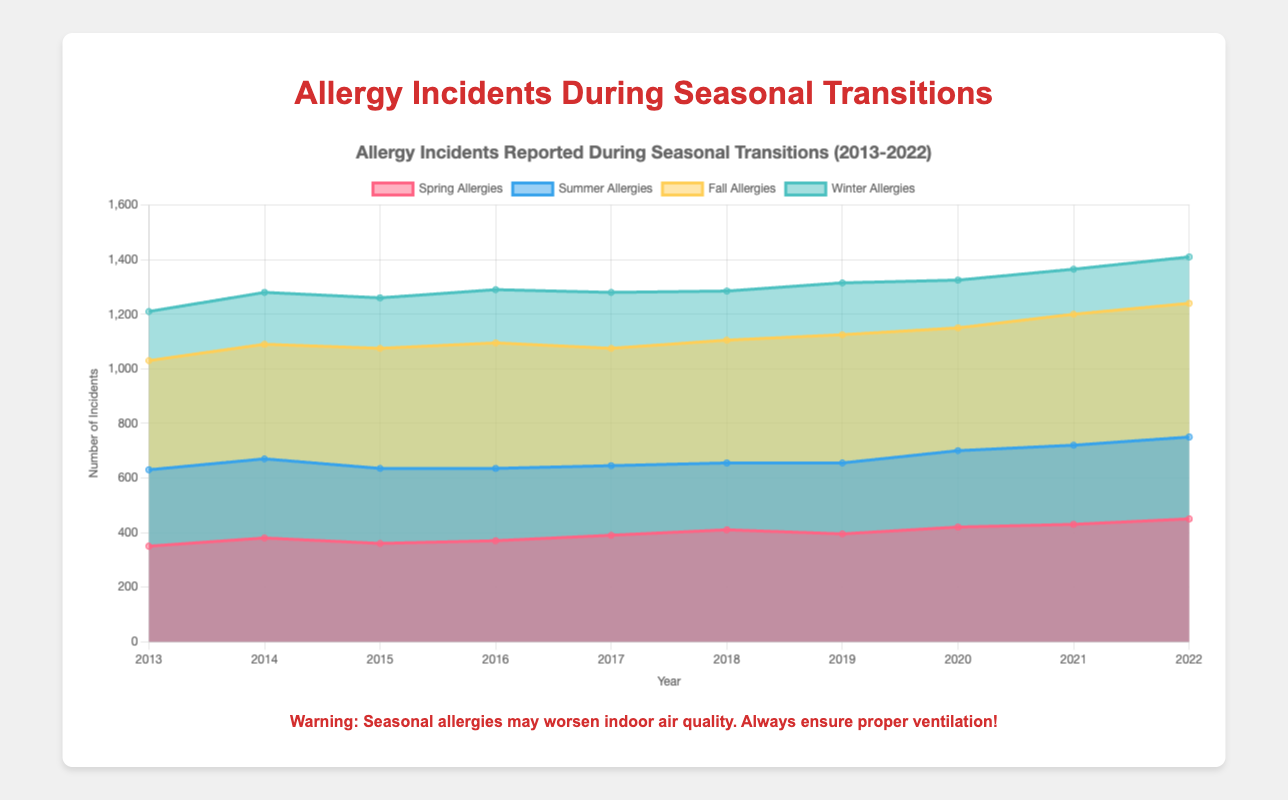What is the title of the chart? The title can be found at the top of the chart. It reads "Allergy Incidents Reported During Seasonal Transitions (2013-2022)"
Answer: Allergy Incidents Reported During Seasonal Transitions (2013-2022) What do the colors represent in the chart? The chart legend indicates that different colors represent the four seasons: Spring (red), Summer (blue), Fall (yellow), and Winter (green)
Answer: Spring, Summer, Fall, Winter How did the number of winter allergy incidents change from 2018 to 2019? Look at the winter allergy data for 2018 and 2019. In 2018, winter allergies were 180; in 2019, they increased to 190
Answer: They increased Which season had the highest number of allergy incidents in 2022? Compare the allergy incidents for each season in 2022. Fall allergies were the highest at 490
Answer: Fall Did the number of spring allergy incidents consistently increase each year from 2013 to 2022? Check the spring allergy data for each year. It consistently increases from 350 in 2013 to 450 in 2022
Answer: Yes What is the average number of fall allergy incidents over the last decade? Sum the fall allergy incidents from 2013 to 2022 and divide by 10: (400 + 420 + 440 + 460 + 430 + 450 + 470 + 450 + 480 + 490) / 10 = 4390 / 10
Answer: 439 Which year had the least number of summer allergy incidents? Check the summer allergy incidents for each year and find the minimum. The least was 245 in 2018
Answer: 2018 How many total allergy incidents were reported in 2020 across all seasons? Sum the incidents for each season in 2020: 420 (Spring) + 280 (Summer) + 450 (Fall) + 175 (Winter) = 1325
Answer: 1325 Between 2013 and 2022, which season exhibited a trend of fluctuating allergy incidents? Compare the data across all seasons; winter allergies show inconsistent numbers (180 to 195 to 180 to 175)
Answer: Winter 